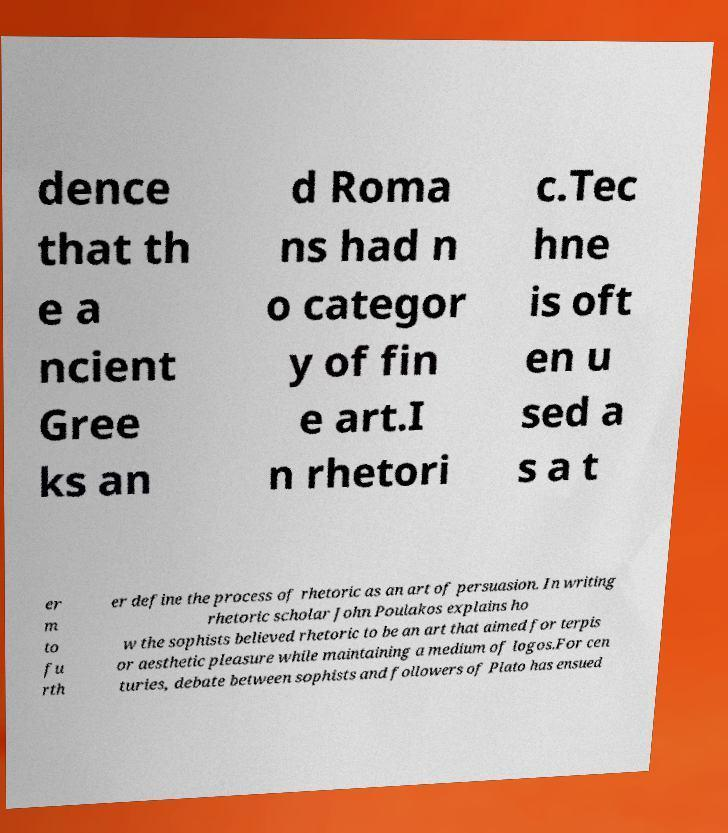Can you accurately transcribe the text from the provided image for me? dence that th e a ncient Gree ks an d Roma ns had n o categor y of fin e art.I n rhetori c.Tec hne is oft en u sed a s a t er m to fu rth er define the process of rhetoric as an art of persuasion. In writing rhetoric scholar John Poulakos explains ho w the sophists believed rhetoric to be an art that aimed for terpis or aesthetic pleasure while maintaining a medium of logos.For cen turies, debate between sophists and followers of Plato has ensued 